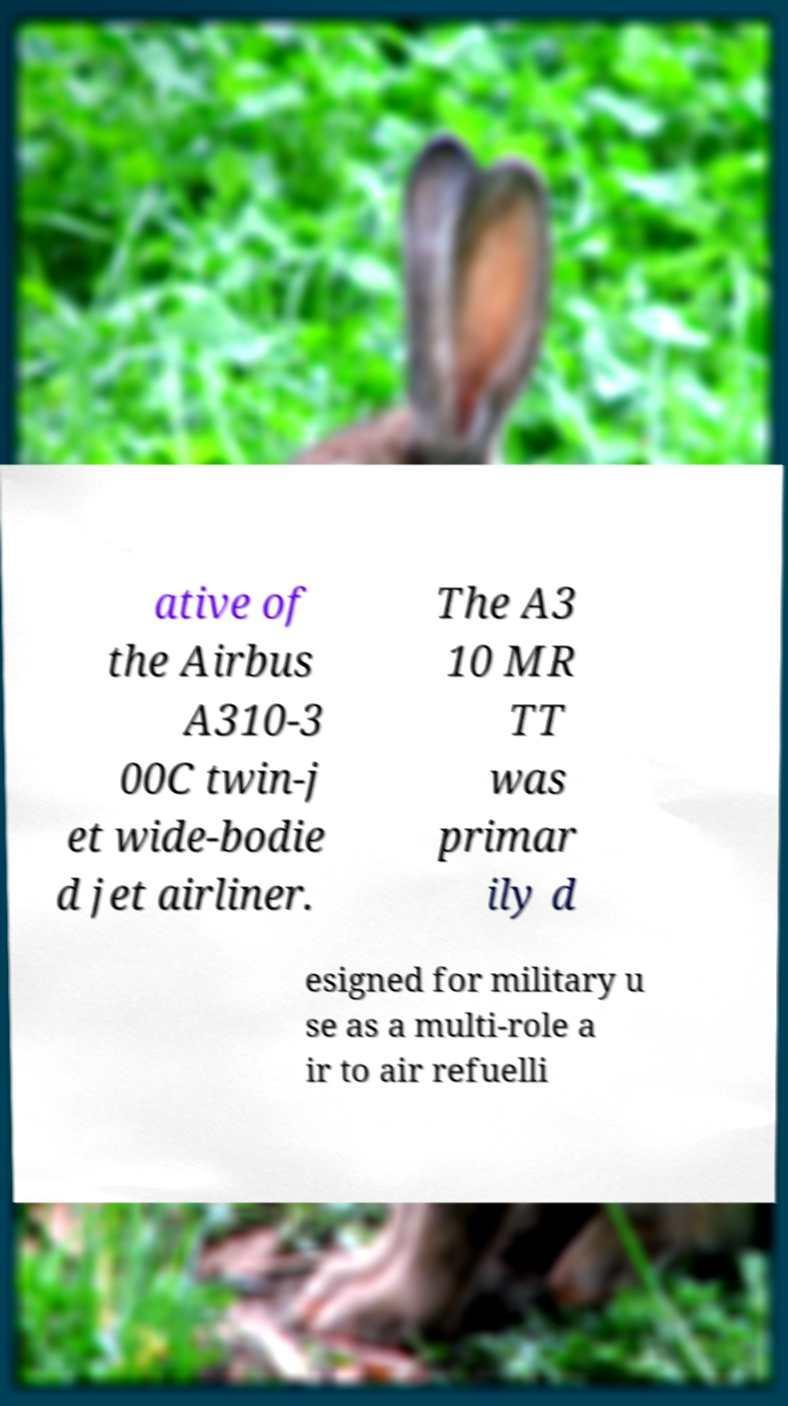I need the written content from this picture converted into text. Can you do that? ative of the Airbus A310-3 00C twin-j et wide-bodie d jet airliner. The A3 10 MR TT was primar ily d esigned for military u se as a multi-role a ir to air refuelli 